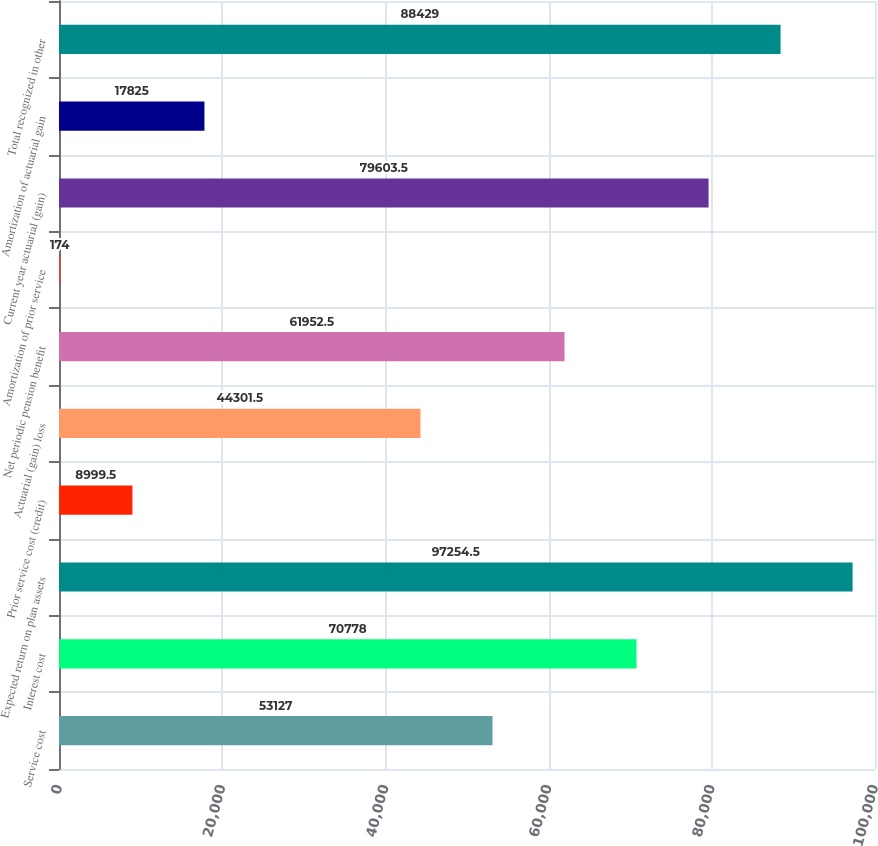<chart> <loc_0><loc_0><loc_500><loc_500><bar_chart><fcel>Service cost<fcel>Interest cost<fcel>Expected return on plan assets<fcel>Prior service cost (credit)<fcel>Actuarial (gain) loss<fcel>Net periodic pension benefit<fcel>Amortization of prior service<fcel>Current year actuarial (gain)<fcel>Amortization of actuarial gain<fcel>Total recognized in other<nl><fcel>53127<fcel>70778<fcel>97254.5<fcel>8999.5<fcel>44301.5<fcel>61952.5<fcel>174<fcel>79603.5<fcel>17825<fcel>88429<nl></chart> 